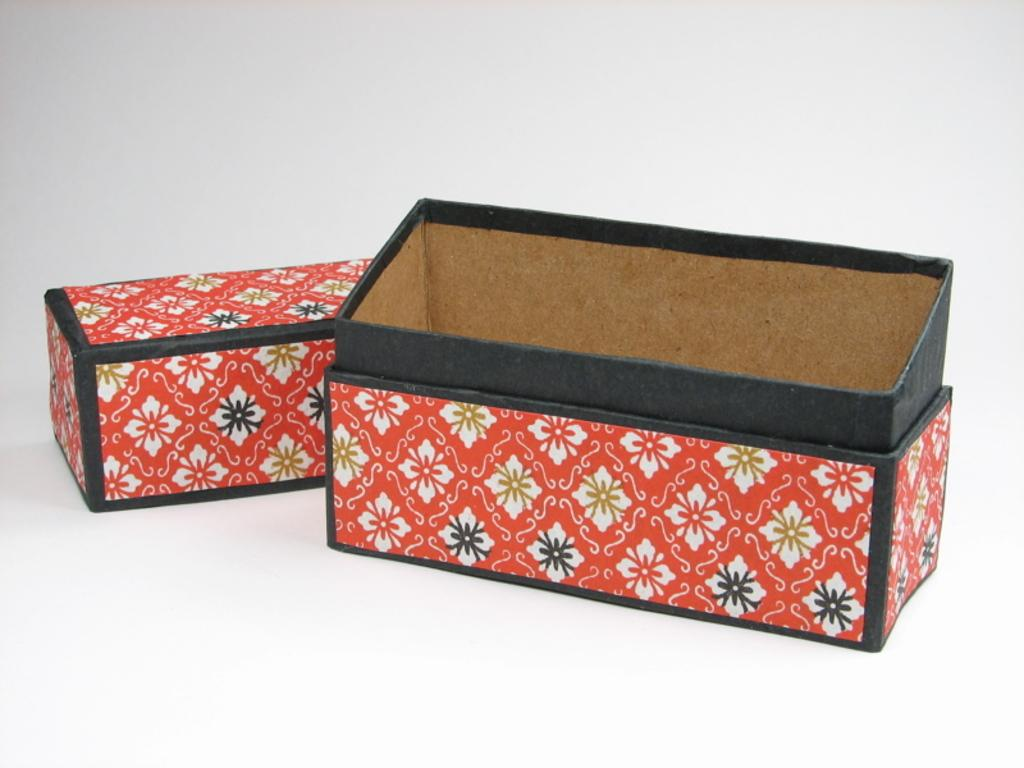What type of objects can be seen in the image? There are cardboard boxes in the image. What color is the background of the image? The background of the image is white. What type of statement can be seen written on the cardboard boxes in the image? There is no statement visible on the cardboard boxes in the image. What color is the thread used to sew the cardboard boxes in the image? There is no thread or sewing visible on the cardboard boxes in the image. 